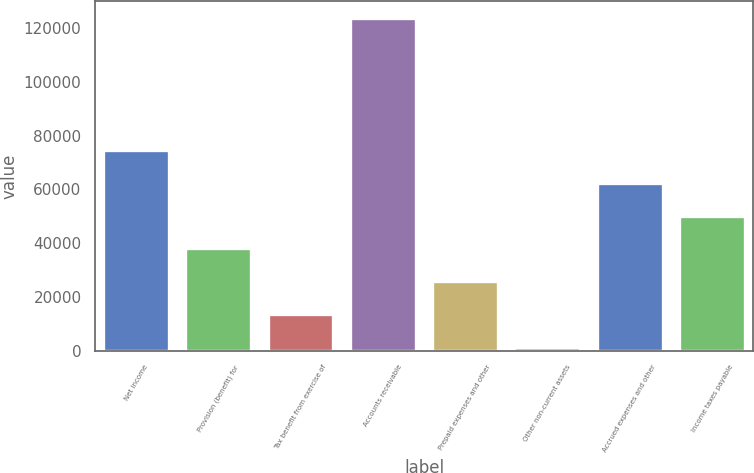<chart> <loc_0><loc_0><loc_500><loc_500><bar_chart><fcel>Net income<fcel>Provision (benefit) for<fcel>Tax benefit from exercise of<fcel>Accounts receivable<fcel>Prepaid expenses and other<fcel>Other non-current assets<fcel>Accrued expenses and other<fcel>Income taxes payable<nl><fcel>74732<fcel>38016.5<fcel>13539.5<fcel>123686<fcel>25778<fcel>1301<fcel>62493.5<fcel>50255<nl></chart> 